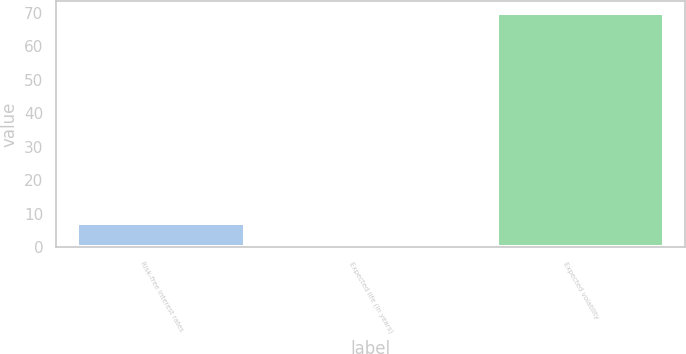<chart> <loc_0><loc_0><loc_500><loc_500><bar_chart><fcel>Risk-free interest rates<fcel>Expected life (in years)<fcel>Expected volatility<nl><fcel>7.45<fcel>0.5<fcel>70<nl></chart> 